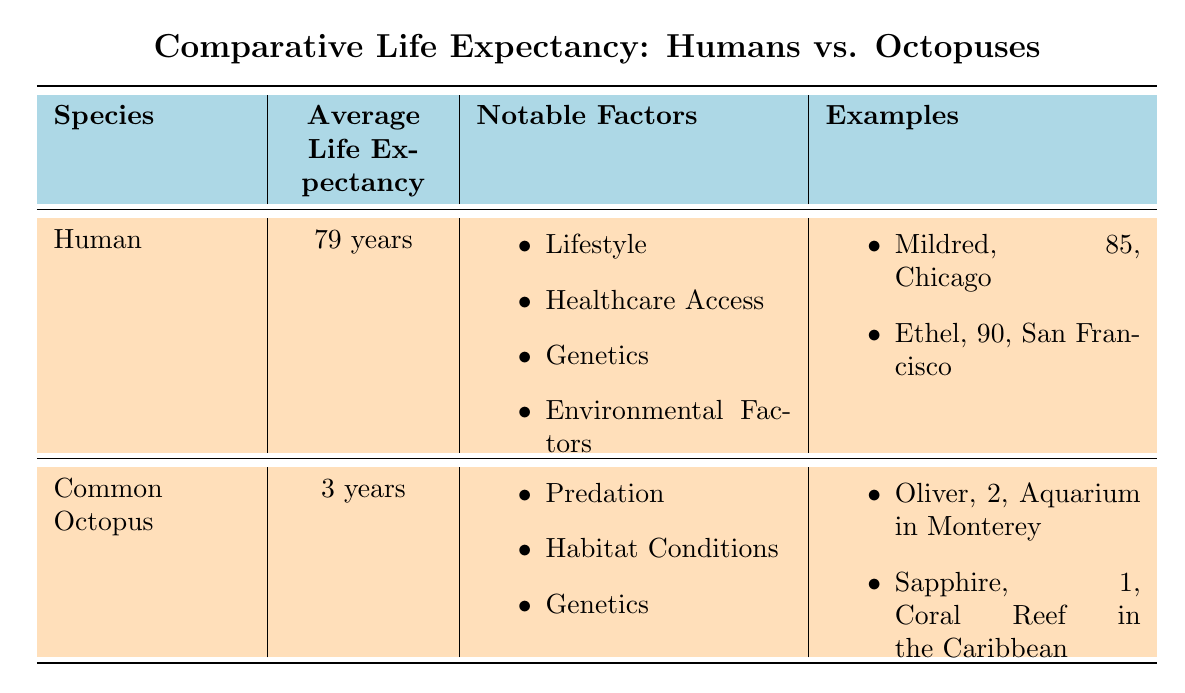What is the average life expectancy of a human? According to the table, the average life expectancy for humans is listed as 79 years.
Answer: 79 years What is the average life expectancy of a common octopus? The table shows that the common octopus has an average life expectancy of 3 years.
Answer: 3 years Are lifestyle factors a notable consideration for human life expectancy? Yes, the table explicitly states that lifestyle is a notable factor for human life expectancy.
Answer: Yes What is the notable factor related to common octopus life expectancy? The notable factors for common octopus are predation, habitat conditions, and genetics. The table lists all three.
Answer: Predation, habitat conditions, genetics How much longer do humans typically live compared to octopuses? To find the difference, subtract the average life expectancy of octopuses (3 years) from that of humans (79 years): 79 - 3 = 76 years. Thus, humans typically live 76 years longer than octopuses.
Answer: 76 years Is either of the humans listed in the examples younger than 80 years old? The table lists two humans, Mildred (85 years) and Ethel (90 years). Both are older than 80 years. Therefore, the statement is false.
Answer: No Which notable factors are associated with human life expectancy? The factors listed in the table for human life expectancy include lifestyle, healthcare access, genetics, and environmental factors.
Answer: Lifestyle, healthcare access, genetics, environmental factors What is the total age of the octopuses mentioned in the examples? The ages of the octopuses listed are Oliver (2 years) and Sapphire (1 year). Adding those together gives 2 + 1 = 3 years total.
Answer: 3 years If we consider both notable factors and examples, what can we say about the life expectancy of octopuses compared to humans? The table indicates that notable factors for humans are aimed at improving longevity, whereas octopuses face challenges such as predation. Humans live significantly longer due to these distinct influencing factors. This comparison shows a vast difference in expected life span because of different environmental and biological influences.
Answer: Humans live significantly longer than octopuses 